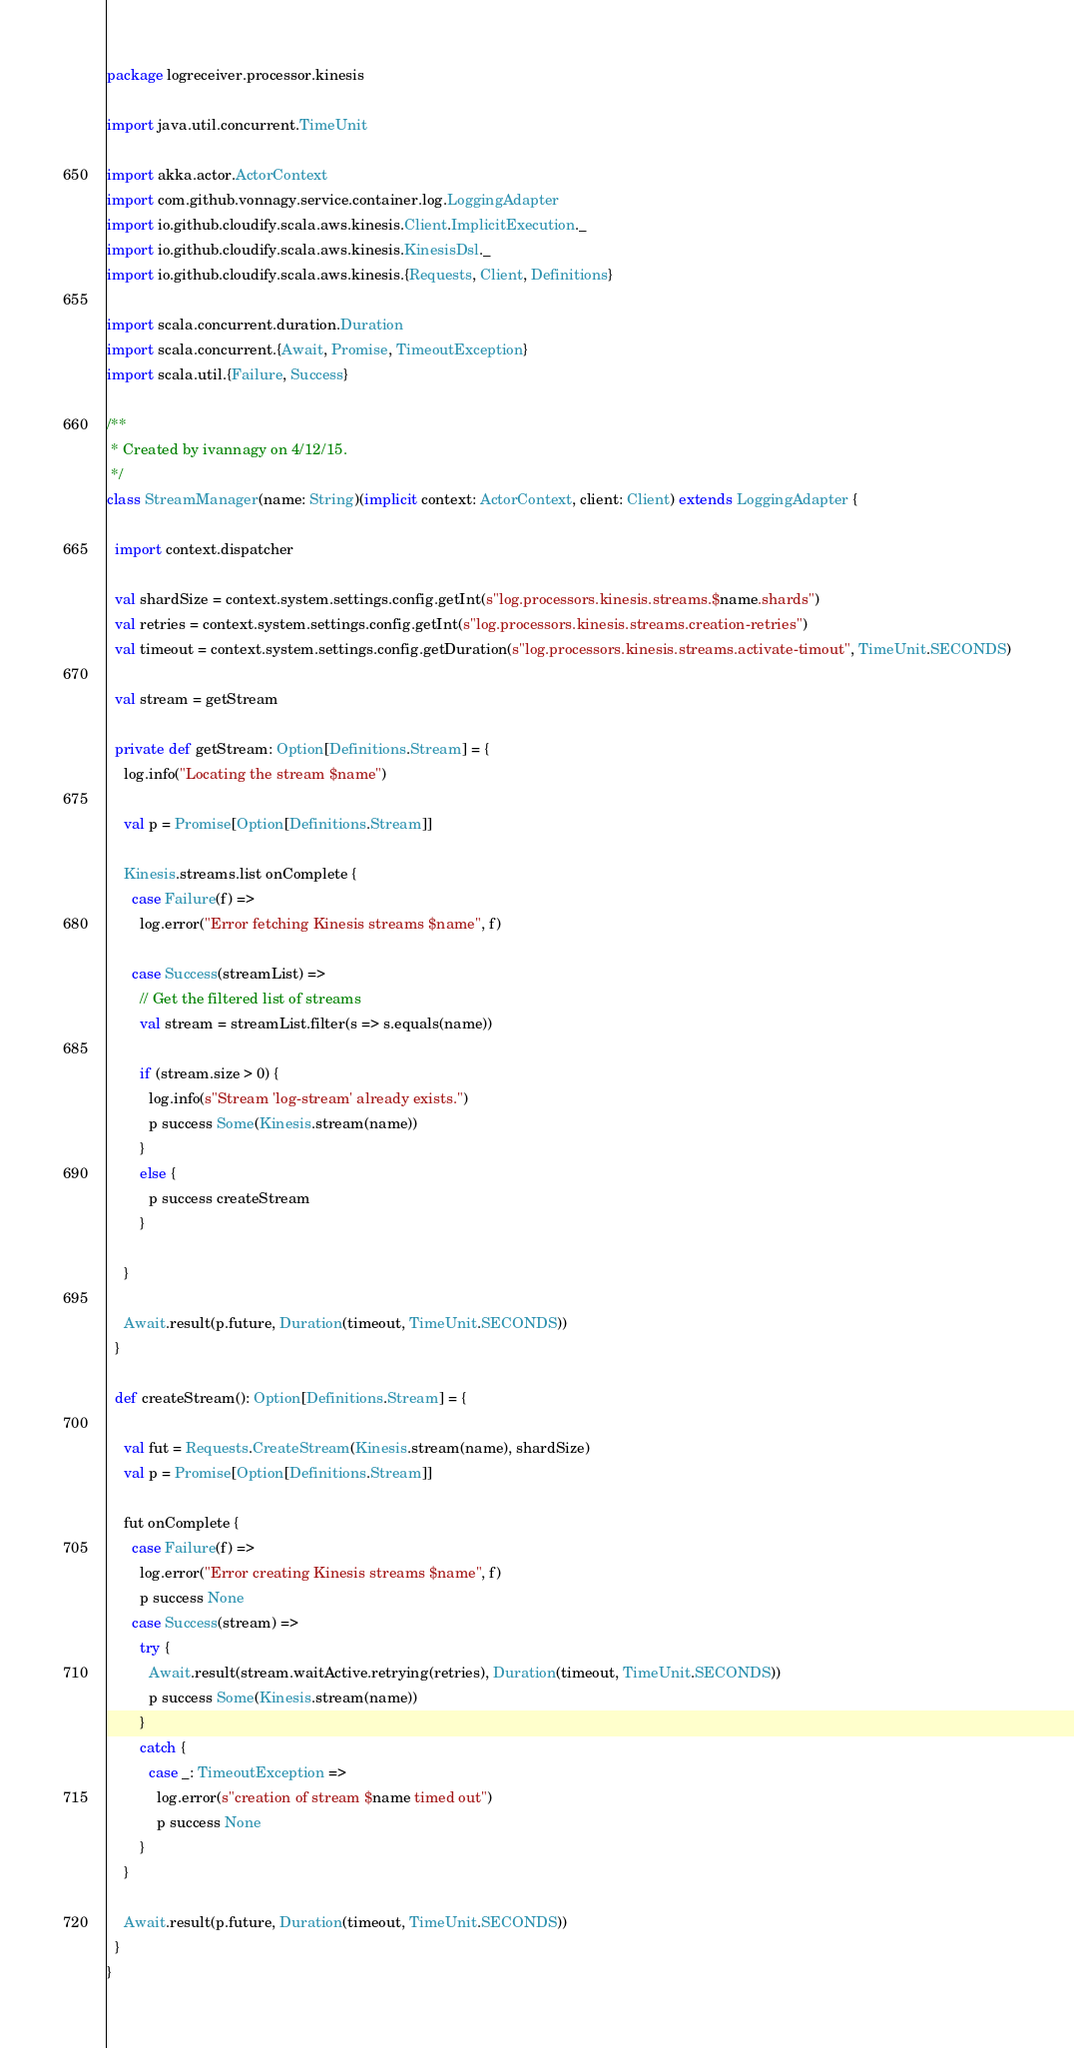Convert code to text. <code><loc_0><loc_0><loc_500><loc_500><_Scala_>package logreceiver.processor.kinesis

import java.util.concurrent.TimeUnit

import akka.actor.ActorContext
import com.github.vonnagy.service.container.log.LoggingAdapter
import io.github.cloudify.scala.aws.kinesis.Client.ImplicitExecution._
import io.github.cloudify.scala.aws.kinesis.KinesisDsl._
import io.github.cloudify.scala.aws.kinesis.{Requests, Client, Definitions}

import scala.concurrent.duration.Duration
import scala.concurrent.{Await, Promise, TimeoutException}
import scala.util.{Failure, Success}

/**
 * Created by ivannagy on 4/12/15.
 */
class StreamManager(name: String)(implicit context: ActorContext, client: Client) extends LoggingAdapter {

  import context.dispatcher

  val shardSize = context.system.settings.config.getInt(s"log.processors.kinesis.streams.$name.shards")
  val retries = context.system.settings.config.getInt(s"log.processors.kinesis.streams.creation-retries")
  val timeout = context.system.settings.config.getDuration(s"log.processors.kinesis.streams.activate-timout", TimeUnit.SECONDS)

  val stream = getStream

  private def getStream: Option[Definitions.Stream] = {
    log.info("Locating the stream $name")

    val p = Promise[Option[Definitions.Stream]]

    Kinesis.streams.list onComplete {
      case Failure(f) =>
        log.error("Error fetching Kinesis streams $name", f)

      case Success(streamList) =>
        // Get the filtered list of streams
        val stream = streamList.filter(s => s.equals(name))

        if (stream.size > 0) {
          log.info(s"Stream 'log-stream' already exists.")
          p success Some(Kinesis.stream(name))
        }
        else {
          p success createStream
        }

    }

    Await.result(p.future, Duration(timeout, TimeUnit.SECONDS))
  }

  def createStream(): Option[Definitions.Stream] = {

    val fut = Requests.CreateStream(Kinesis.stream(name), shardSize)
    val p = Promise[Option[Definitions.Stream]]

    fut onComplete {
      case Failure(f) =>
        log.error("Error creating Kinesis streams $name", f)
        p success None
      case Success(stream) =>
        try {
          Await.result(stream.waitActive.retrying(retries), Duration(timeout, TimeUnit.SECONDS))
          p success Some(Kinesis.stream(name))
        }
        catch {
          case _: TimeoutException =>
            log.error(s"creation of stream $name timed out")
            p success None
        }
    }

    Await.result(p.future, Duration(timeout, TimeUnit.SECONDS))
  }
}
</code> 